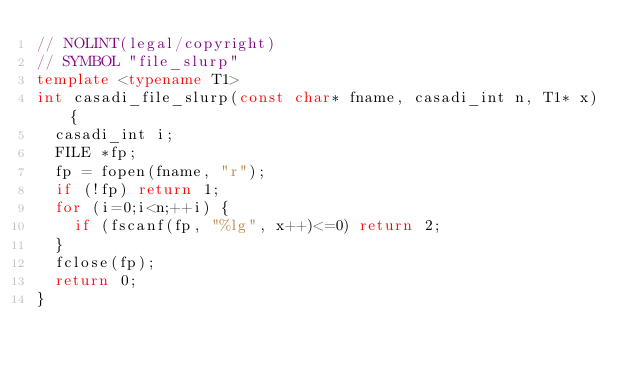Convert code to text. <code><loc_0><loc_0><loc_500><loc_500><_C++_>// NOLINT(legal/copyright)
// SYMBOL "file_slurp"
template <typename T1>
int casadi_file_slurp(const char* fname, casadi_int n, T1* x) {
  casadi_int i;
  FILE *fp;
  fp = fopen(fname, "r");
  if (!fp) return 1;
  for (i=0;i<n;++i) {
    if (fscanf(fp, "%lg", x++)<=0) return 2;
  }
  fclose(fp);
  return 0;
}
</code> 